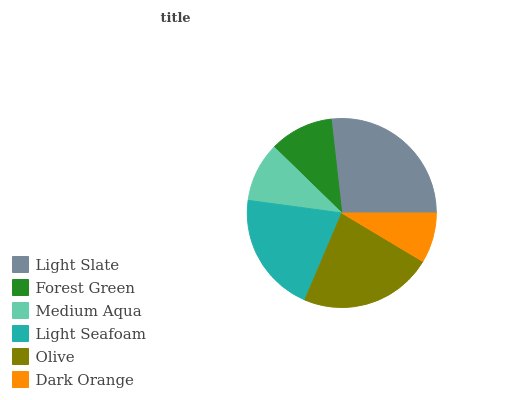Is Dark Orange the minimum?
Answer yes or no. Yes. Is Light Slate the maximum?
Answer yes or no. Yes. Is Forest Green the minimum?
Answer yes or no. No. Is Forest Green the maximum?
Answer yes or no. No. Is Light Slate greater than Forest Green?
Answer yes or no. Yes. Is Forest Green less than Light Slate?
Answer yes or no. Yes. Is Forest Green greater than Light Slate?
Answer yes or no. No. Is Light Slate less than Forest Green?
Answer yes or no. No. Is Light Seafoam the high median?
Answer yes or no. Yes. Is Forest Green the low median?
Answer yes or no. Yes. Is Olive the high median?
Answer yes or no. No. Is Dark Orange the low median?
Answer yes or no. No. 